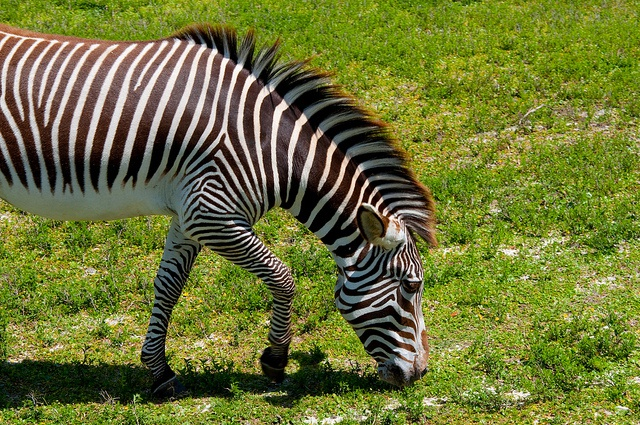Describe the objects in this image and their specific colors. I can see a zebra in olive, black, gray, lightgray, and maroon tones in this image. 